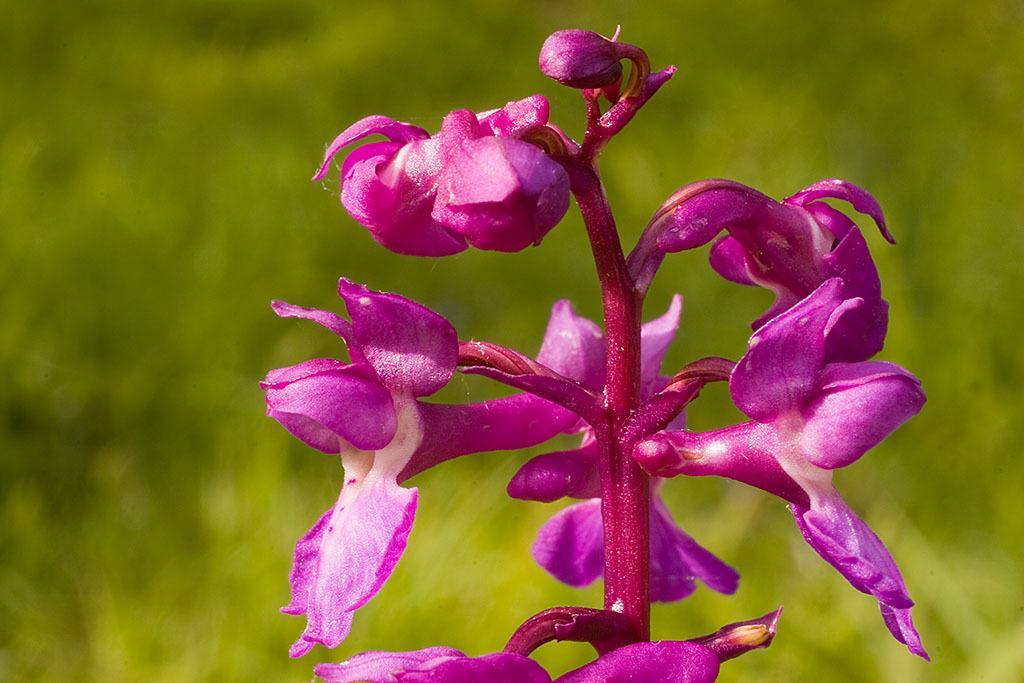Describe this image in one or two sentences. At the front of the image there is a pink stem with pink flowers. Behind the flowers there is a green background. 